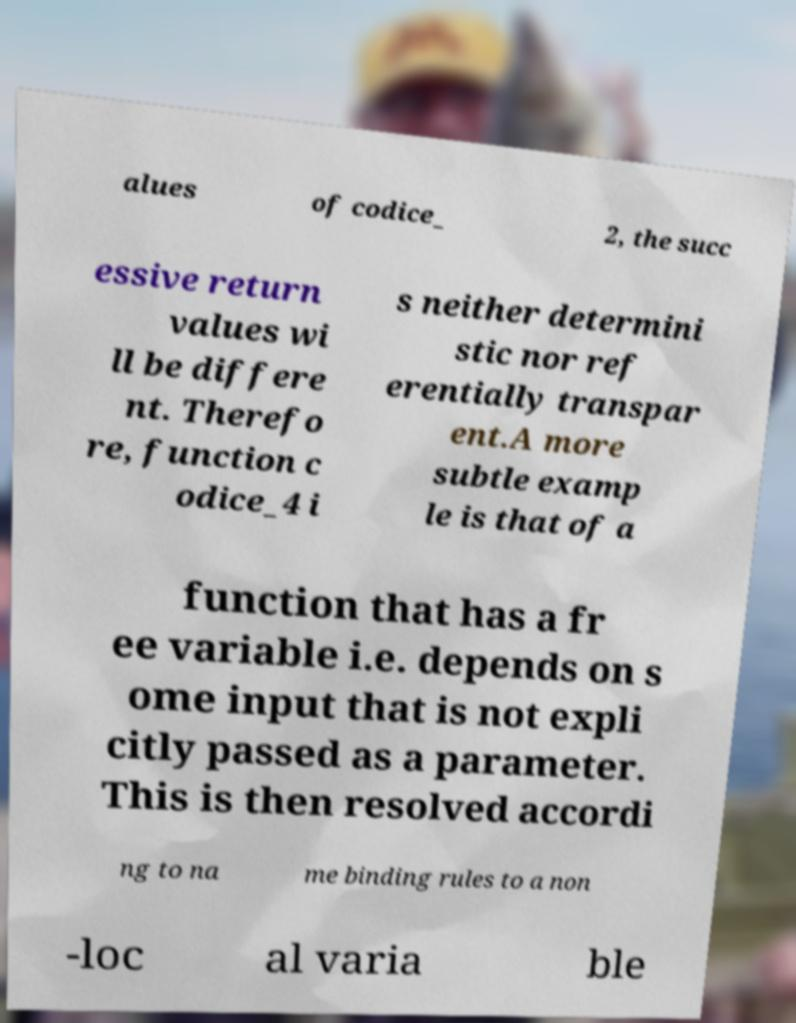Could you assist in decoding the text presented in this image and type it out clearly? alues of codice_ 2, the succ essive return values wi ll be differe nt. Therefo re, function c odice_4 i s neither determini stic nor ref erentially transpar ent.A more subtle examp le is that of a function that has a fr ee variable i.e. depends on s ome input that is not expli citly passed as a parameter. This is then resolved accordi ng to na me binding rules to a non -loc al varia ble 